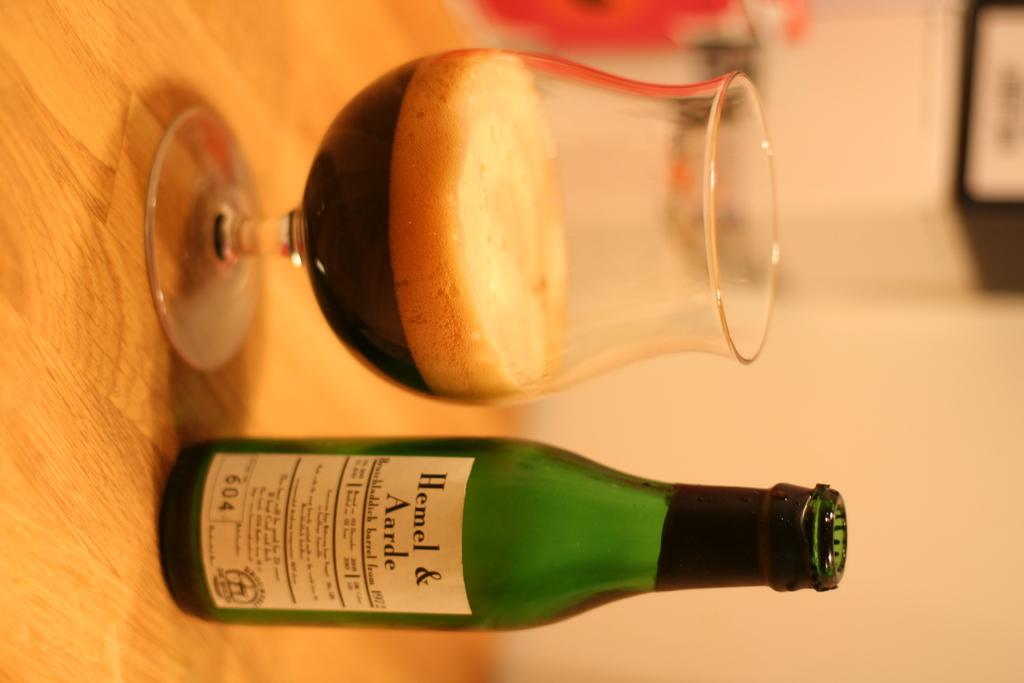<image>
Give a short and clear explanation of the subsequent image. A bottle of Hemel & Aarde from 1972 and numbered 604, sits next to a glass of the beverage on a wood table. 